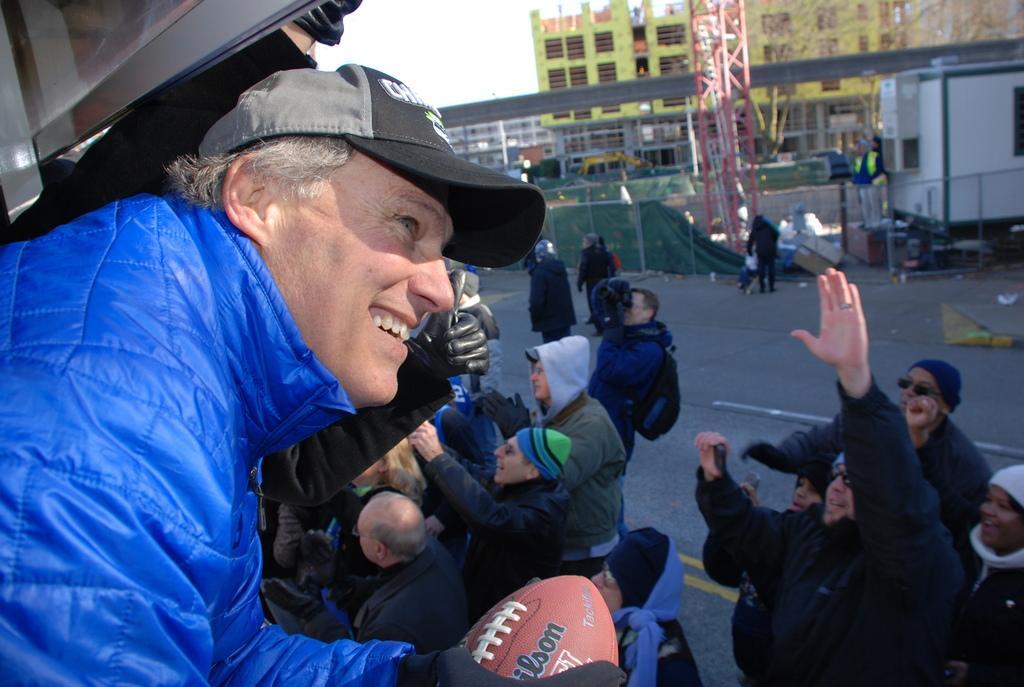How would you summarize this image in a sentence or two? In the picture we can see a man from the vehicle looking outside and he is wearing a blue color jacket, cap and holding a rugby ball and he is also wearing a cap and beside him we can see some people are standing on the road and raising the hands and one person is holding a camera and capturing something and behind him we can see a fencing and behind it we can see a bridge and behind it we can see some buildings and behind it we can see a sky. 